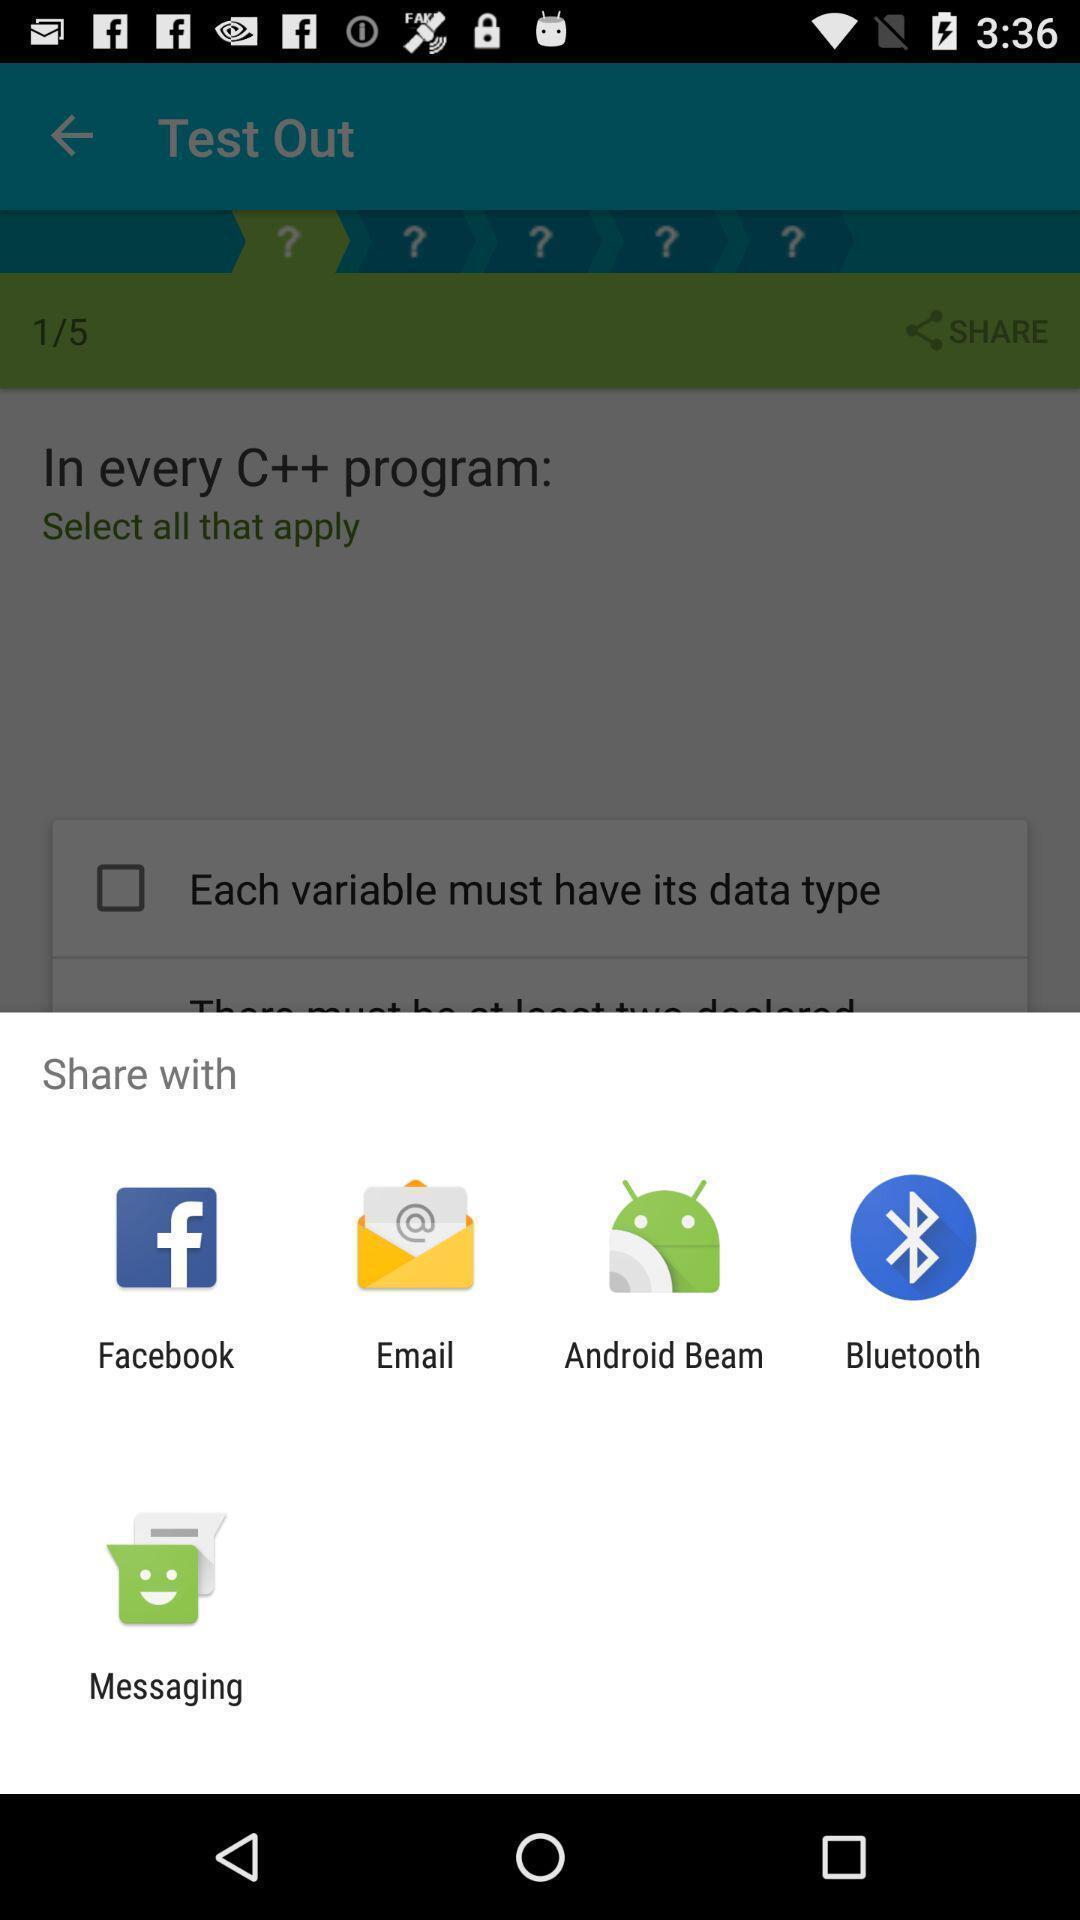What is the overall content of this screenshot? Pop-up for sharing with other social apps. 